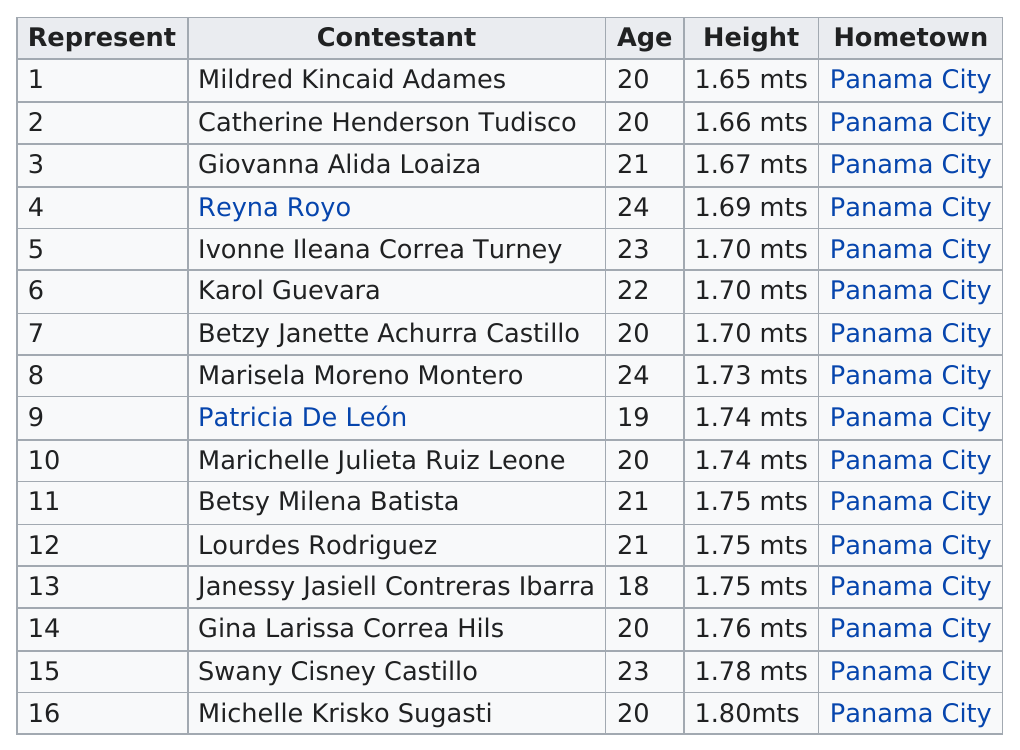Highlight a few significant elements in this photo. Reyna Royo is 24 years old, and Marisela Moreno Montero is another person who is 24 years old. I am sorry, but the information you have provided does not form a complete question or request. Can you please provide more information or a specific question so that I may assist you better? Six out of the total number of contestants are 20 years old. There were 8 contestants under the age of 21. There are at least 8 contestants who are at least 21 years old. 